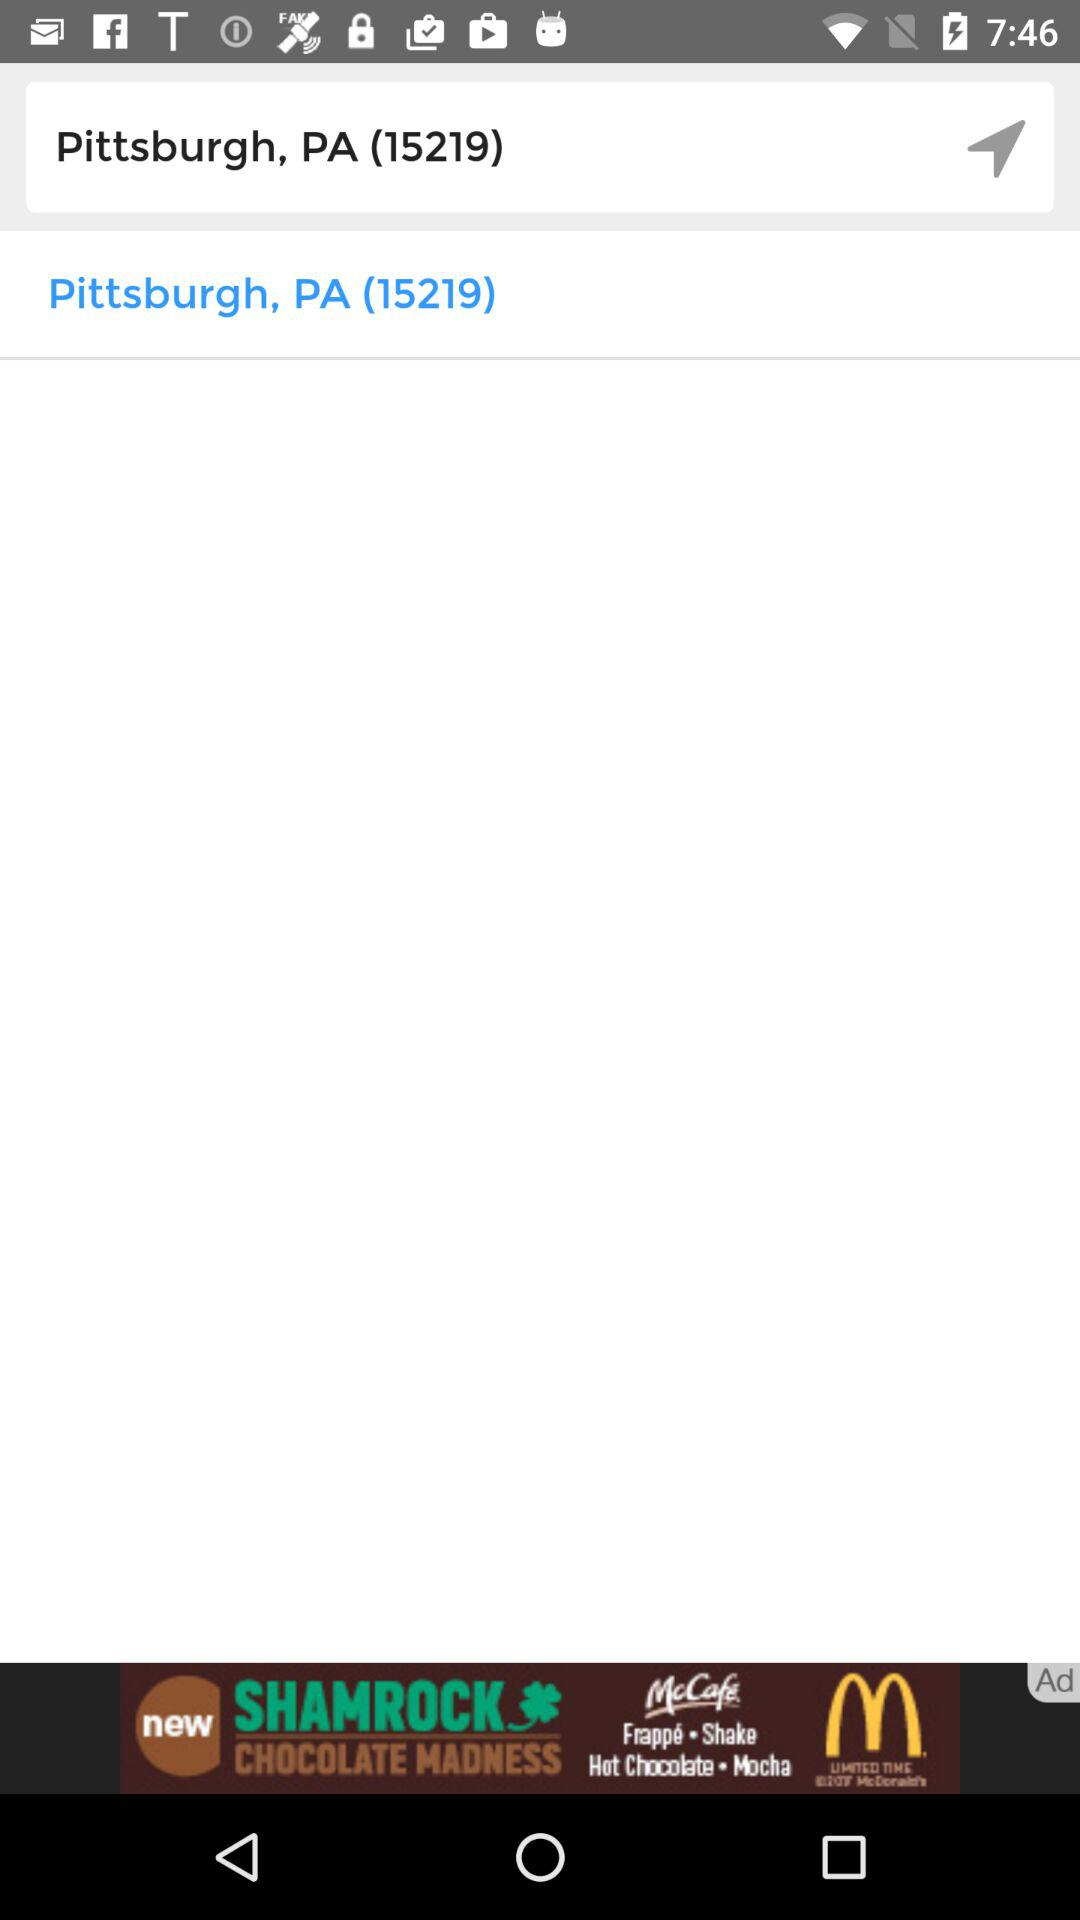What is the location? The location is Pittsburgh, PA (15219). 